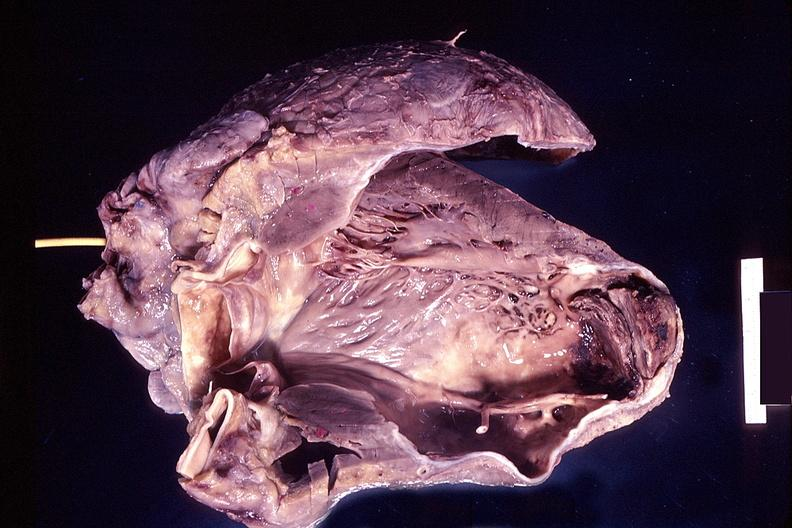how does this image show heart, old myocardial infarction?
Answer the question using a single word or phrase. With aneurysm formation 